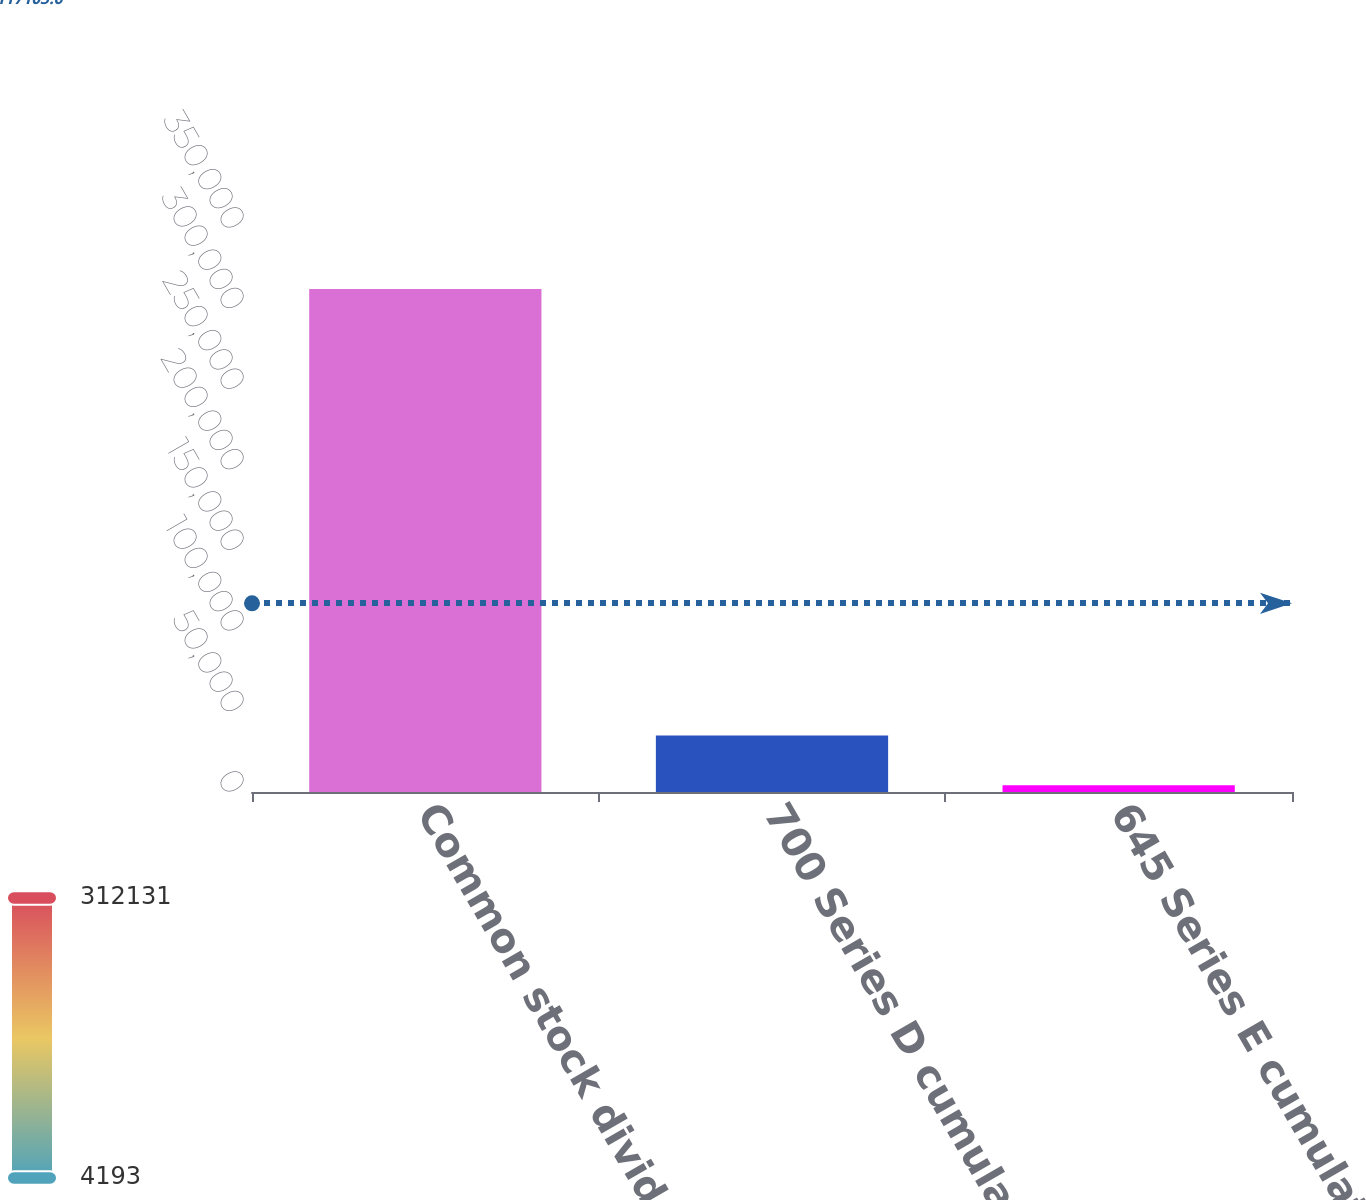<chart> <loc_0><loc_0><loc_500><loc_500><bar_chart><fcel>Common stock dividends<fcel>700 Series D cumulative<fcel>645 Series E cumulative<nl><fcel>312131<fcel>34986.8<fcel>4193<nl></chart> 